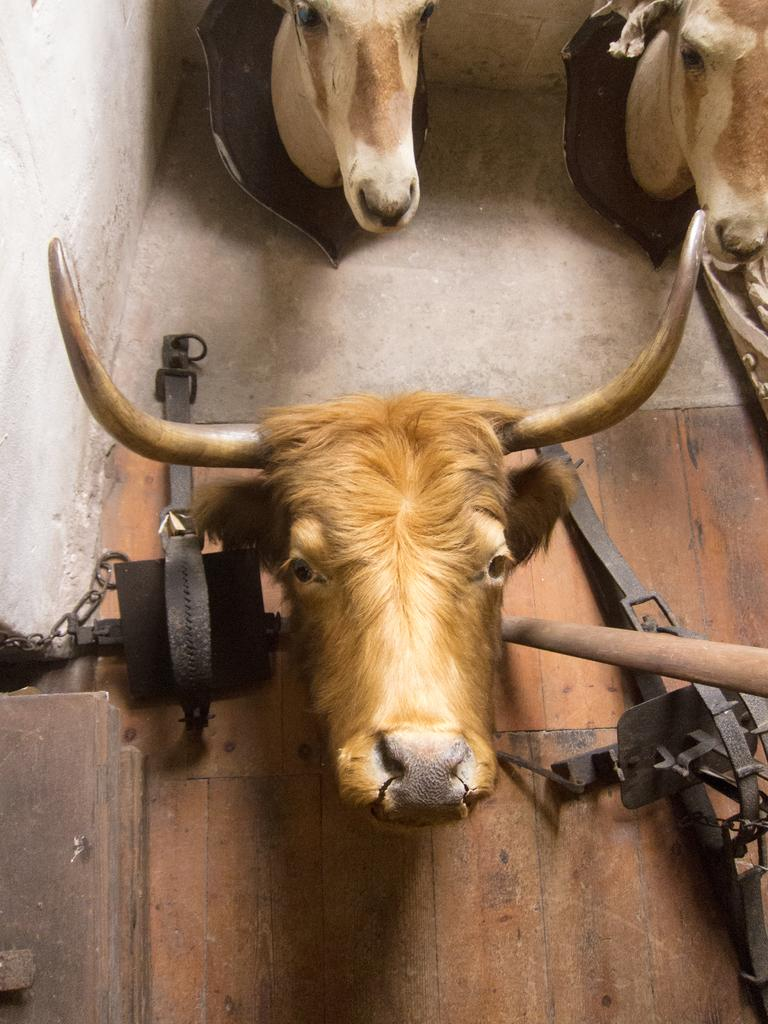What type of objects are featured on the wooden board in the image? There are animal heads in the image. Can you describe the wooden board in the image? The image features a wooden board. What is attached to the wooden board? There is an object attached to the wooden board. What type of peace symbol can be seen on the wooden board in the image? There is no peace symbol present on the wooden board in the image. How does the argument between the animal heads resolve in the image? There is no argument between the animal heads in the image, as they are simply objects mounted on a wooden board. 